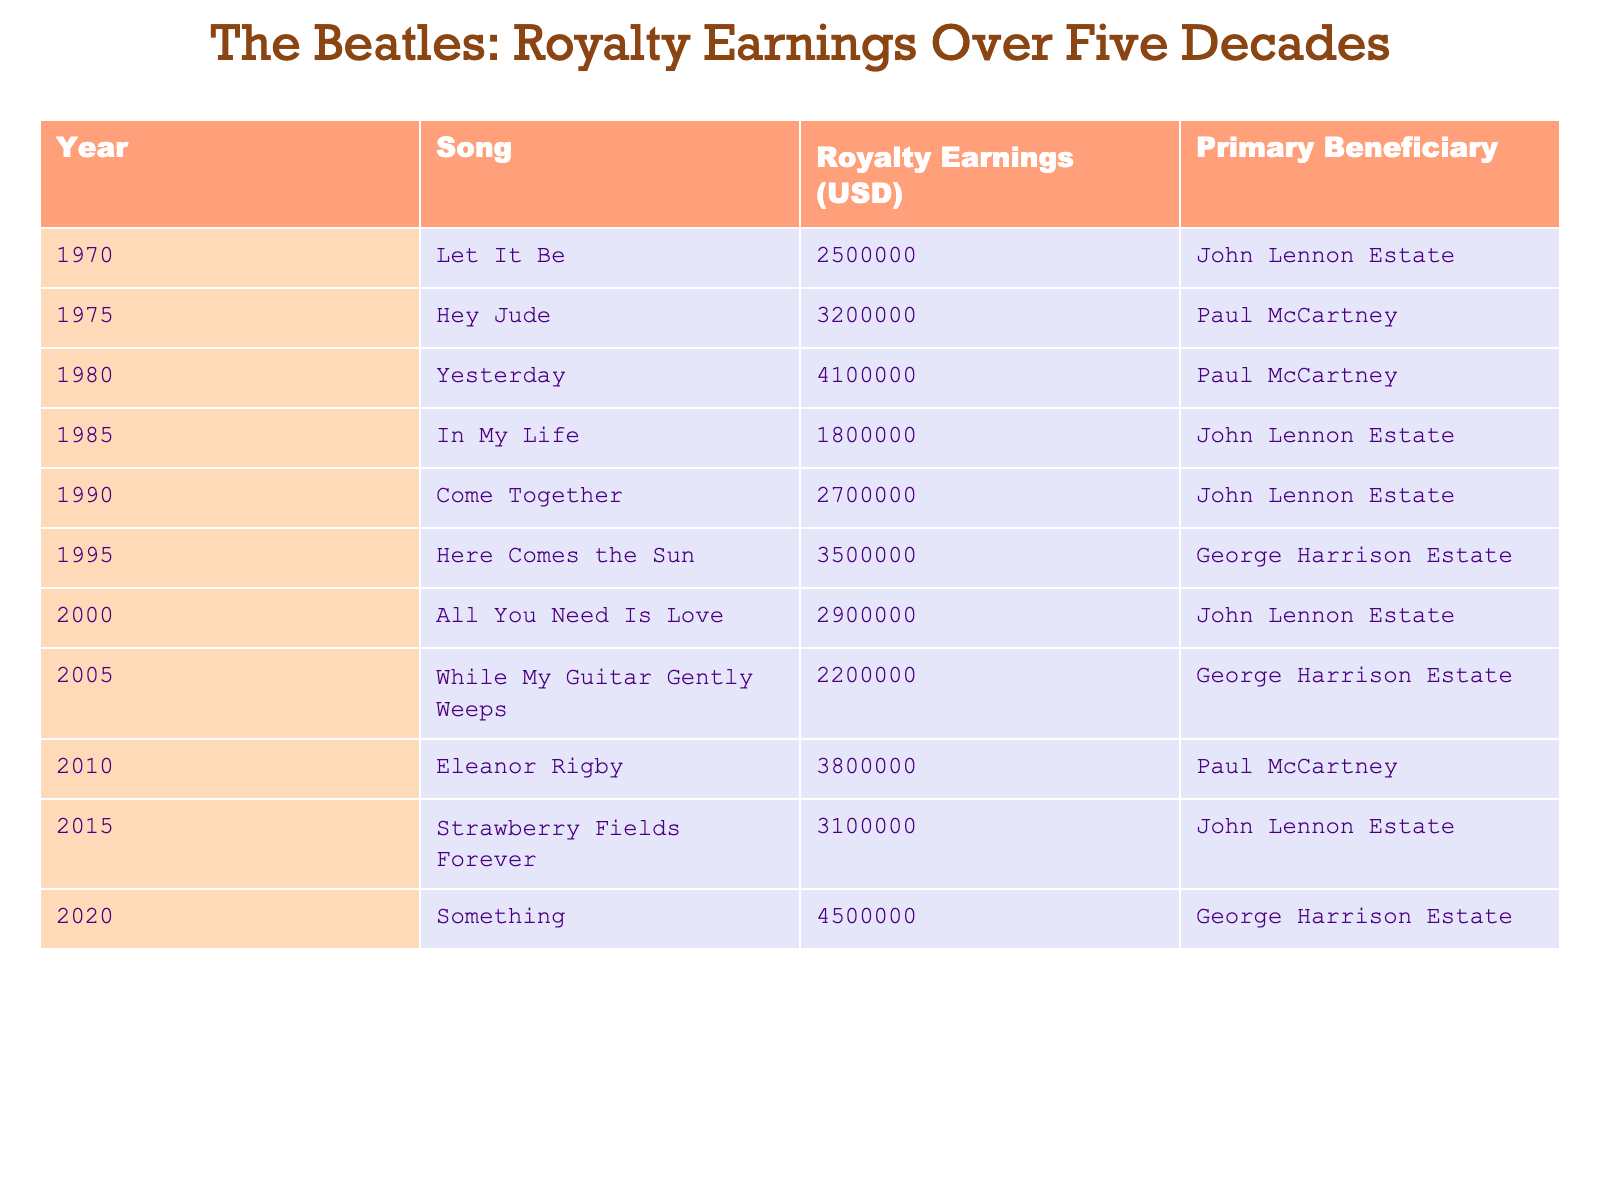What is the total royalty earnings from all the songs listed? To find the total royalty earnings, sum the individual earnings from each row: 2500000 + 3200000 + 4100000 + 1800000 + 2700000 + 3500000 + 2900000 + 2200000 + 3800000 + 3100000 + 4500000 = 28800000.
Answer: 28800000 Which song earned the highest royalty? By examining the 'Royalty Earnings' column, the highest amount is 4500000, which corresponds to the song 'Something'.
Answer: Something Who is the primary beneficiary of the song 'Here Comes the Sun'? The 'Primary Beneficiary' column indicates that 'Here Comes the Sun' has George Harrison Estate as its beneficiary.
Answer: George Harrison Estate What was the royalty earning for 'In My Life'? The table shows that 'In My Life' earned a total of 1800000.
Answer: 1800000 How many songs had royalty earnings greater than 3000000? Count the songs in the table with earnings exceeding 3000000: 'Hey Jude', 'Yesterday', 'Here Comes the Sun', 'Eleanor Rigby', 'Something'. That totals to 5 songs.
Answer: 5 What is the average royalty earnings for the songs listed? To calculate the average, sum the earnings (28800000) and divide by the number of songs (11), thus 28800000/11 = 2618181.82.
Answer: 2618181.82 Is 'Paul McCartney' a beneficiary for any song from the 1980s? Check the 'Primary Beneficiary' for the songs released in the 1980s: 'Yesterday' is his song. This confirms that he is a beneficiary.
Answer: Yes Which decade had the highest royalty earnings? Assess the total earnings for each decade: 1970s = 5700000, 1980s = 1800000, 1990s = 5400000, 2000s = 5100000, 2010s = 6900000, 2020s = 4500000. The highest is 2010s with 6900000.
Answer: 2010s How much more did 'Hey Jude' earn compared to 'While My Guitar Gently Weeps'? Subtract the earnings of 'While My Guitar Gently Weeps' (2200000) from 'Hey Jude' (3200000): 3200000 - 2200000 = 1000000.
Answer: 1000000 Was 'Yesterday' the only song benefiting Paul McCartney? Review the 'Primary Beneficiary' column for Paul McCartney's entries: both 'Hey Jude' and 'Yesterday' list him as a beneficiary. Hence, he has more than one.
Answer: No 